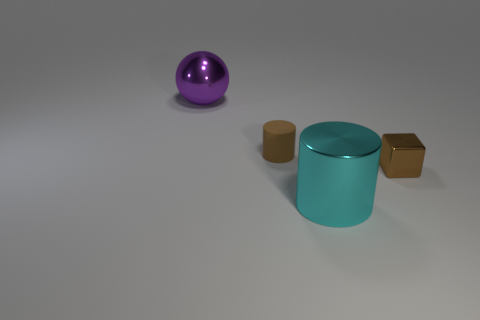Does the image suggest any particular theme or concept? The image might be interpreted as an exploration of geometry and color contrast, emphasizing the simplicity of forms and how they relate to each other within a space. It also invokes a sense of minimalism and could be viewed as playing with the idea of balance and proportion.  Could there be any functional purpose for these objects, or does this seem purely aesthetic? Without additional context, it's hard to determine any functional purpose, so the setup appears to be purely aesthetic. It seems to focus on visual pleasure derived from symmetry, color contrasts, and the cleanliness of simple geometrical forms. 